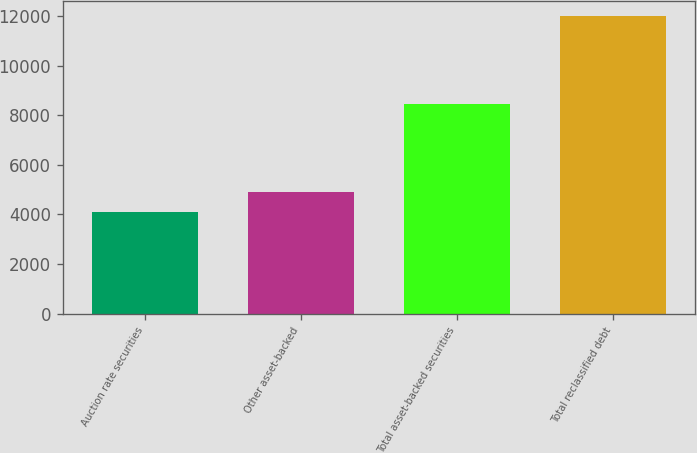<chart> <loc_0><loc_0><loc_500><loc_500><bar_chart><fcel>Auction rate securities<fcel>Other asset-backed<fcel>Total asset-backed securities<fcel>Total reclassified debt<nl><fcel>4110<fcel>4899.1<fcel>8444<fcel>12001<nl></chart> 